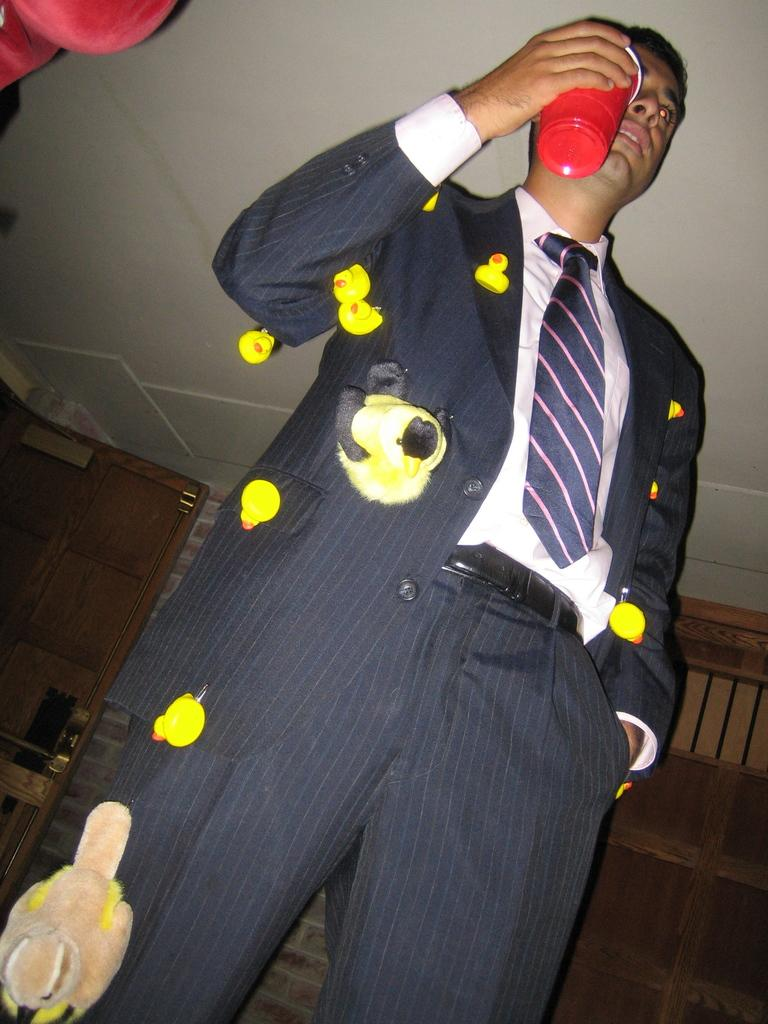What is the man in the image doing? The man is standing in the image. What is the man holding in his hand? The man is holding a glass in his hand. What type of toys are attached to the man's dress? There are duck toys attached to the man's dress. What is behind the man in the image? There is a wall behind the man. What is visible at the top of the image? The ceiling is visible at the top of the image. What type of detail can be seen on the loaf of bread in the image? There is no loaf of bread present in the image. What is the man doing on top of the table in the image? The man is not on top of a table in the image; he is standing on the ground. 